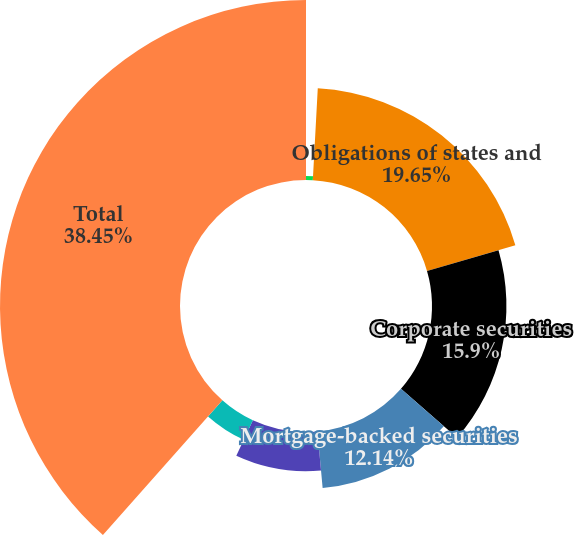<chart> <loc_0><loc_0><loc_500><loc_500><pie_chart><fcel>US Treasury securities and<fcel>Obligations of states and<fcel>Corporate securities<fcel>Mortgage-backed securities<fcel>Foreign government securities<fcel>Foreign corporate securities<fcel>Total<nl><fcel>0.86%<fcel>19.65%<fcel>15.9%<fcel>12.14%<fcel>8.38%<fcel>4.62%<fcel>38.45%<nl></chart> 